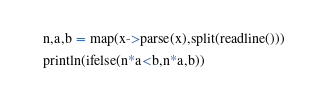Convert code to text. <code><loc_0><loc_0><loc_500><loc_500><_Julia_>n,a,b = map(x->parse(x),split(readline()))
println(ifelse(n*a<b,n*a,b))</code> 